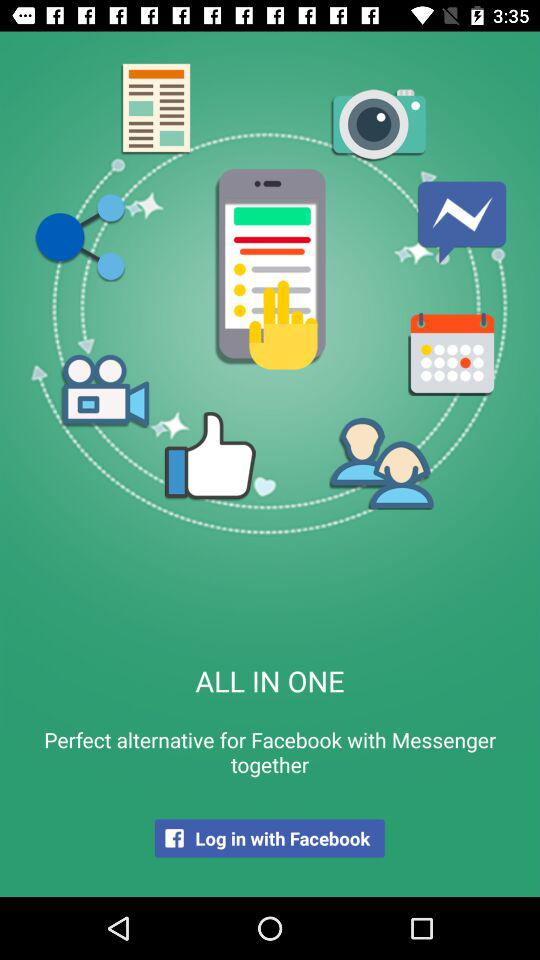What account can I use to log in? The account that you can use to log in is "Facebook". 